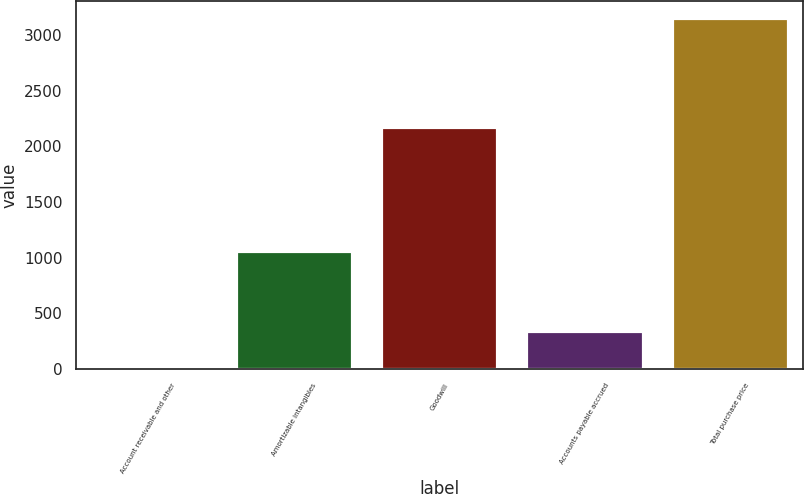<chart> <loc_0><loc_0><loc_500><loc_500><bar_chart><fcel>Account receivable and other<fcel>Amortizable intangibles<fcel>Goodwill<fcel>Accounts payable accrued<fcel>Total purchase price<nl><fcel>27<fcel>1060<fcel>2177<fcel>339.3<fcel>3150<nl></chart> 